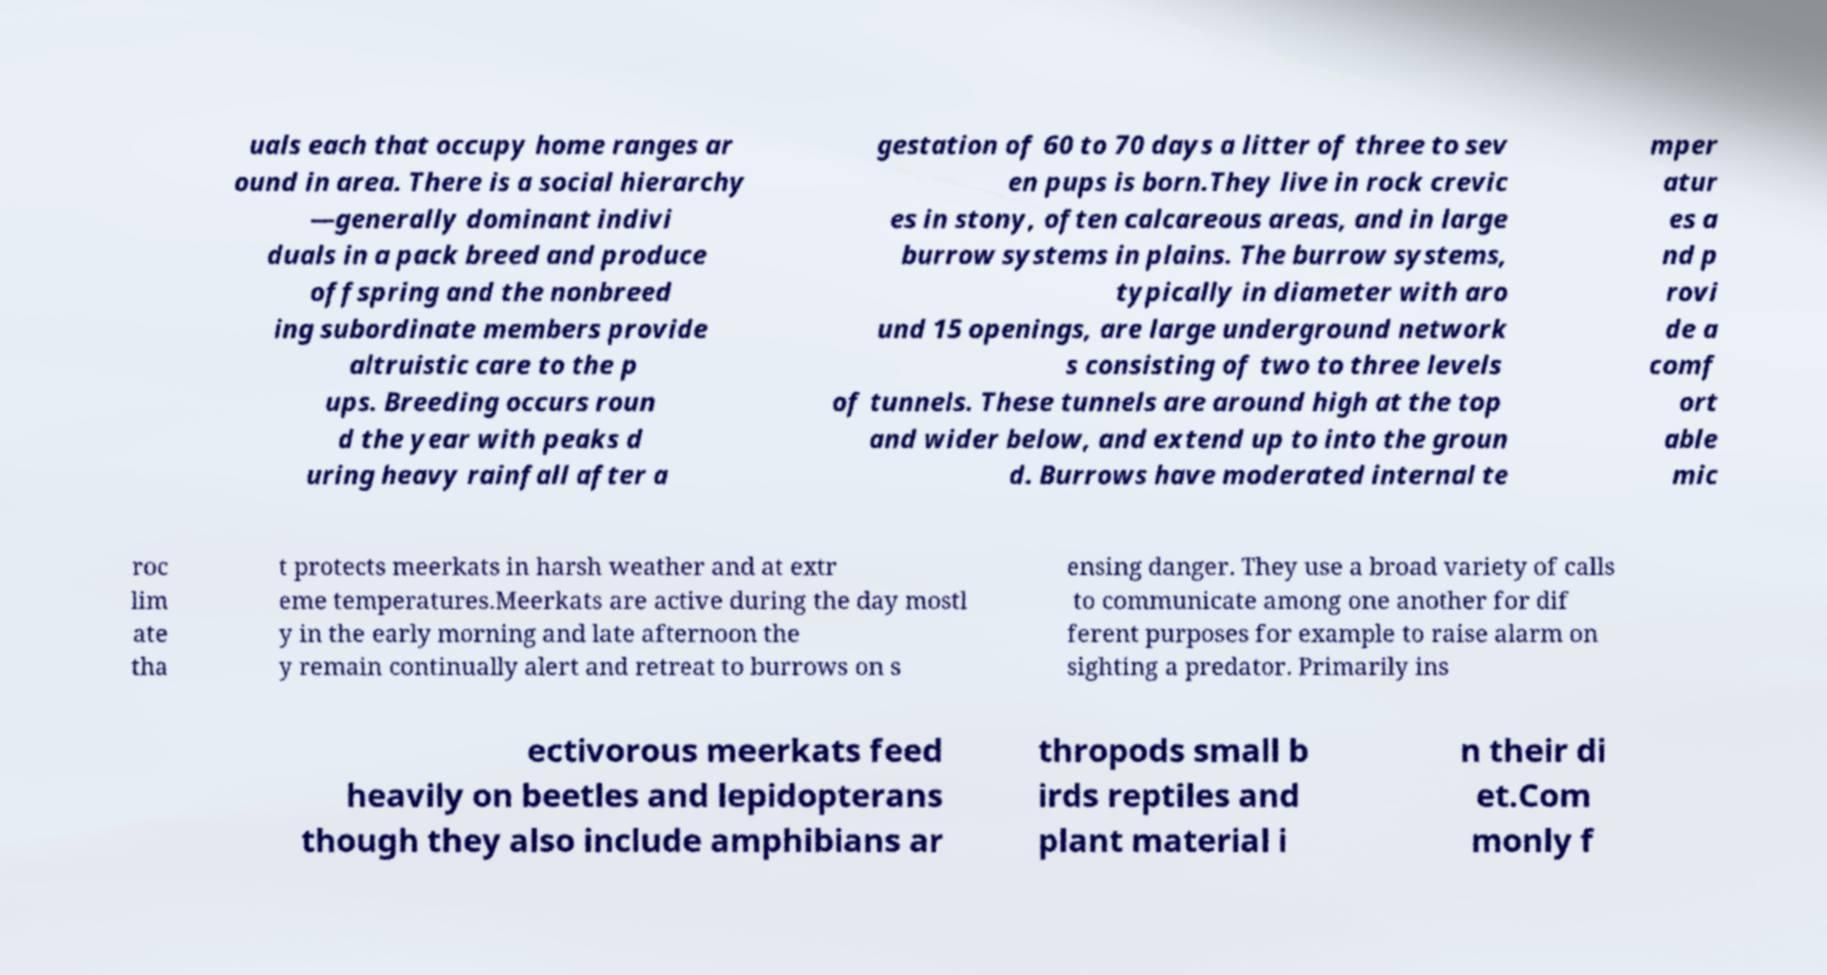What messages or text are displayed in this image? I need them in a readable, typed format. uals each that occupy home ranges ar ound in area. There is a social hierarchy —generally dominant indivi duals in a pack breed and produce offspring and the nonbreed ing subordinate members provide altruistic care to the p ups. Breeding occurs roun d the year with peaks d uring heavy rainfall after a gestation of 60 to 70 days a litter of three to sev en pups is born.They live in rock crevic es in stony, often calcareous areas, and in large burrow systems in plains. The burrow systems, typically in diameter with aro und 15 openings, are large underground network s consisting of two to three levels of tunnels. These tunnels are around high at the top and wider below, and extend up to into the groun d. Burrows have moderated internal te mper atur es a nd p rovi de a comf ort able mic roc lim ate tha t protects meerkats in harsh weather and at extr eme temperatures.Meerkats are active during the day mostl y in the early morning and late afternoon the y remain continually alert and retreat to burrows on s ensing danger. They use a broad variety of calls to communicate among one another for dif ferent purposes for example to raise alarm on sighting a predator. Primarily ins ectivorous meerkats feed heavily on beetles and lepidopterans though they also include amphibians ar thropods small b irds reptiles and plant material i n their di et.Com monly f 